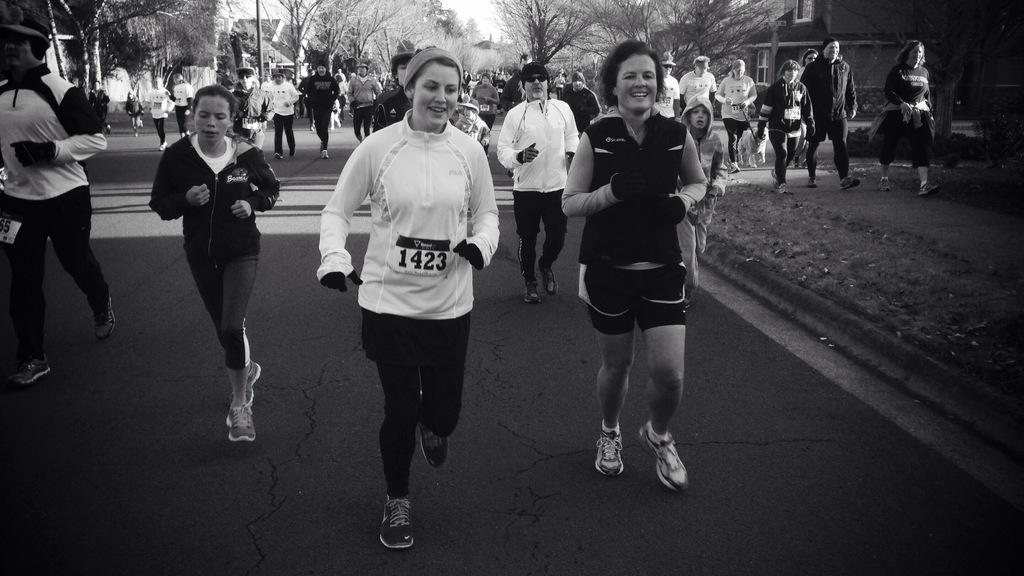What are the people in the image doing? There are people running on the road in the image. What can be seen in the background of the image? Trees and houses are visible in the image. How many people are present in the image? There is a woman and a man in the image. What is the man wearing on his head? The man is wearing a cap. What type of wire is being used to collect honey in the image? There is no wire or honey present in the image; it features people running on the road with trees and houses in the background. 